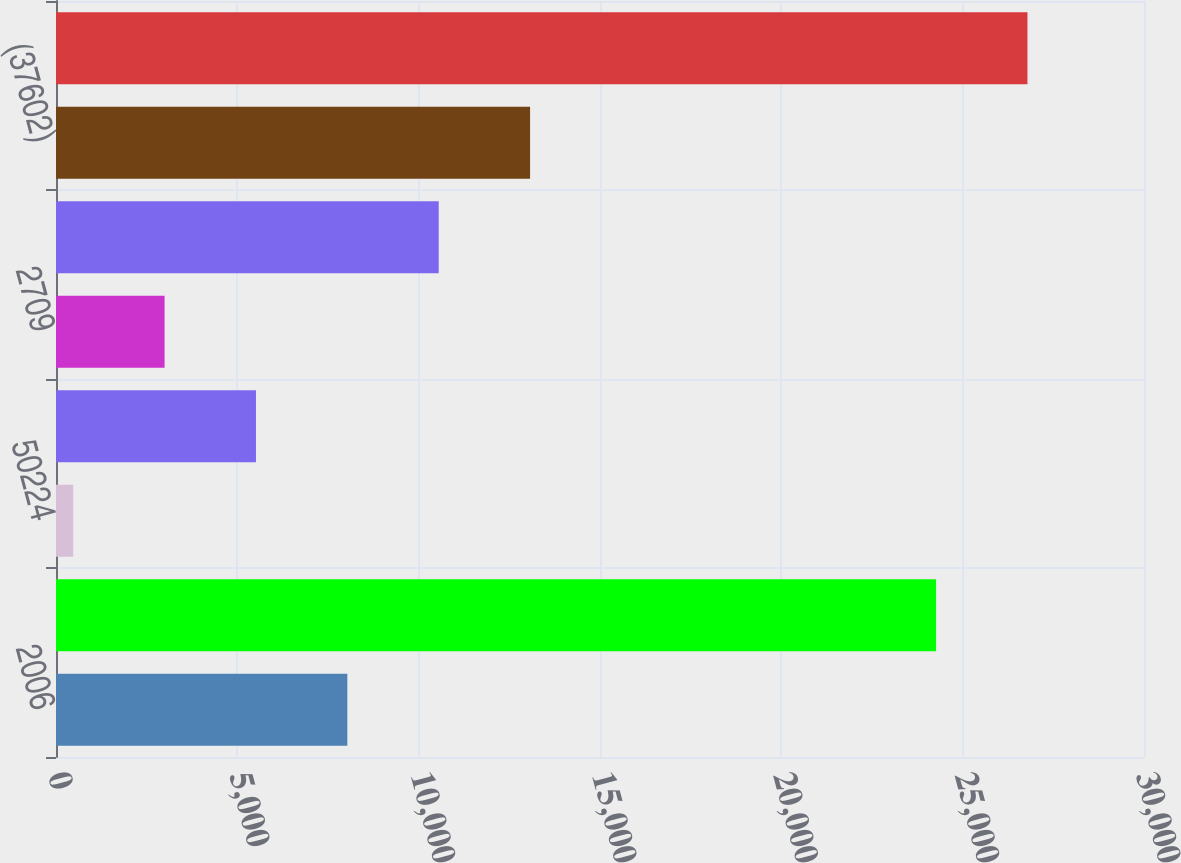<chart> <loc_0><loc_0><loc_500><loc_500><bar_chart><fcel>2006<fcel>1236379<fcel>50224<fcel>72246<fcel>2709<fcel>9213<fcel>(37602)<fcel>1334528<nl><fcel>8033.2<fcel>24267<fcel>475<fcel>5513.8<fcel>2994.4<fcel>10552.6<fcel>13072<fcel>26786.4<nl></chart> 